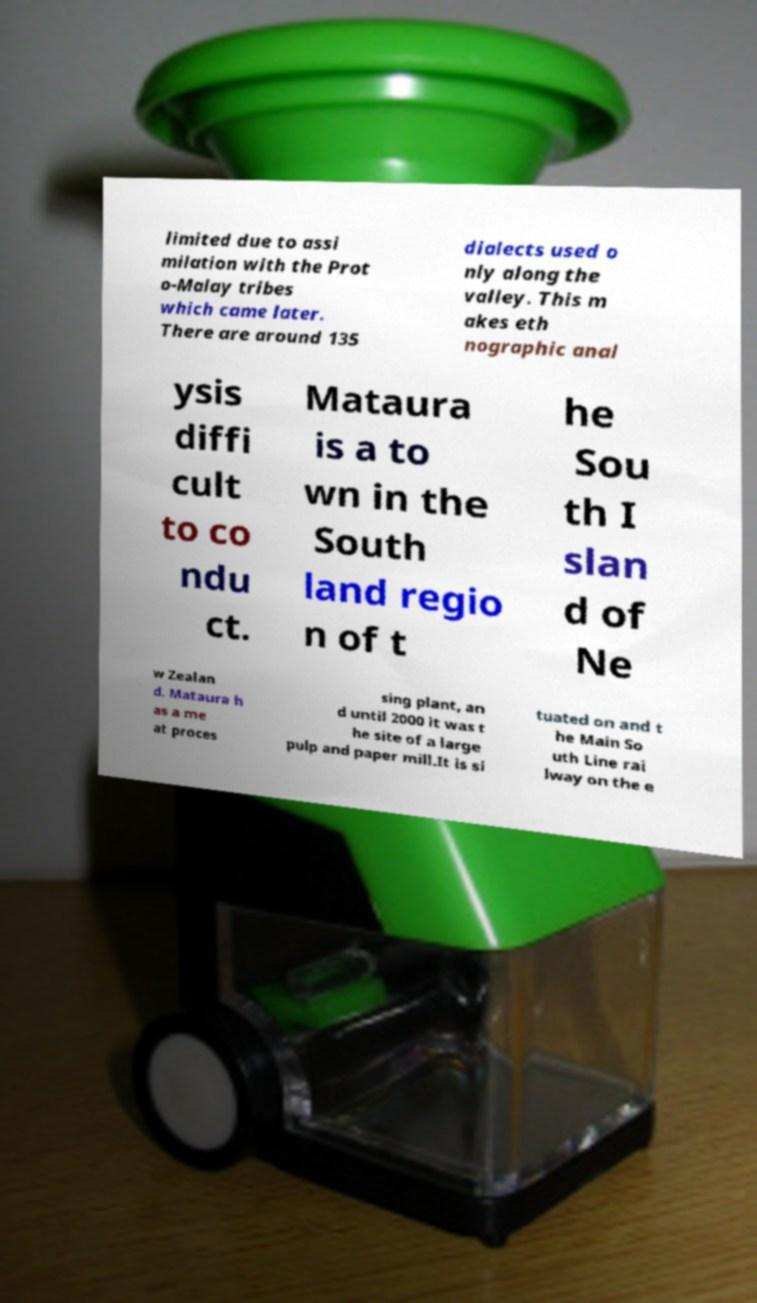I need the written content from this picture converted into text. Can you do that? limited due to assi milation with the Prot o-Malay tribes which came later. There are around 135 dialects used o nly along the valley. This m akes eth nographic anal ysis diffi cult to co ndu ct. Mataura is a to wn in the South land regio n of t he Sou th I slan d of Ne w Zealan d. Mataura h as a me at proces sing plant, an d until 2000 it was t he site of a large pulp and paper mill.It is si tuated on and t he Main So uth Line rai lway on the e 